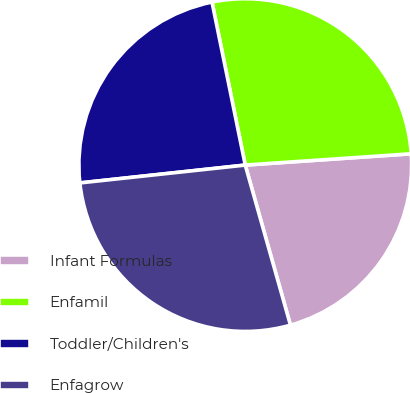<chart> <loc_0><loc_0><loc_500><loc_500><pie_chart><fcel>Infant Formulas<fcel>Enfamil<fcel>Toddler/Children's<fcel>Enfagrow<nl><fcel>21.7%<fcel>27.12%<fcel>23.51%<fcel>27.67%<nl></chart> 